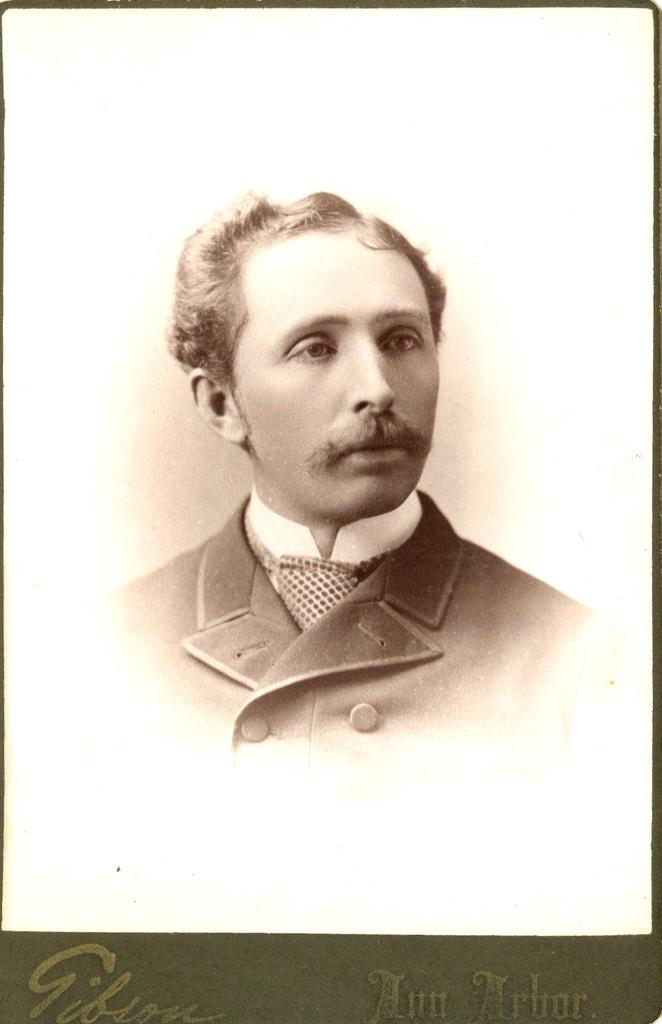What is the main subject of the image? There is a photo of a person in the image. What color is the background of the image? The background of the image is white. Is there any text present in the image? Yes, there is text written at the bottom of the image. What type of bell can be seen hanging from the person's stocking in the image? There is no bell or stocking present in the image; it only features a photo of a person with text at the bottom. 